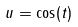<formula> <loc_0><loc_0><loc_500><loc_500>u = \cos ( t )</formula> 